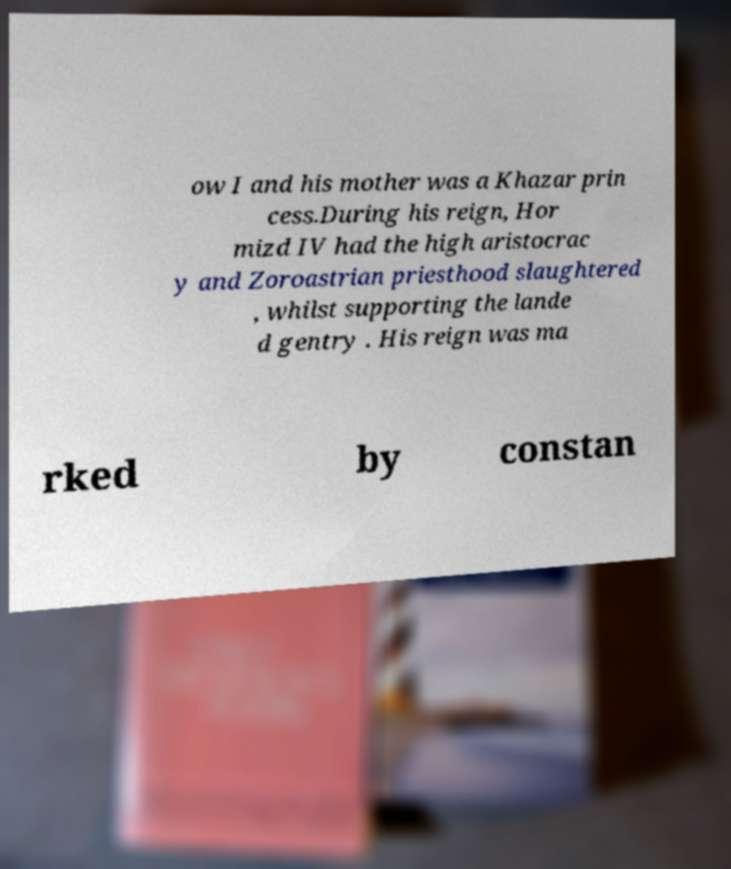For documentation purposes, I need the text within this image transcribed. Could you provide that? ow I and his mother was a Khazar prin cess.During his reign, Hor mizd IV had the high aristocrac y and Zoroastrian priesthood slaughtered , whilst supporting the lande d gentry . His reign was ma rked by constan 